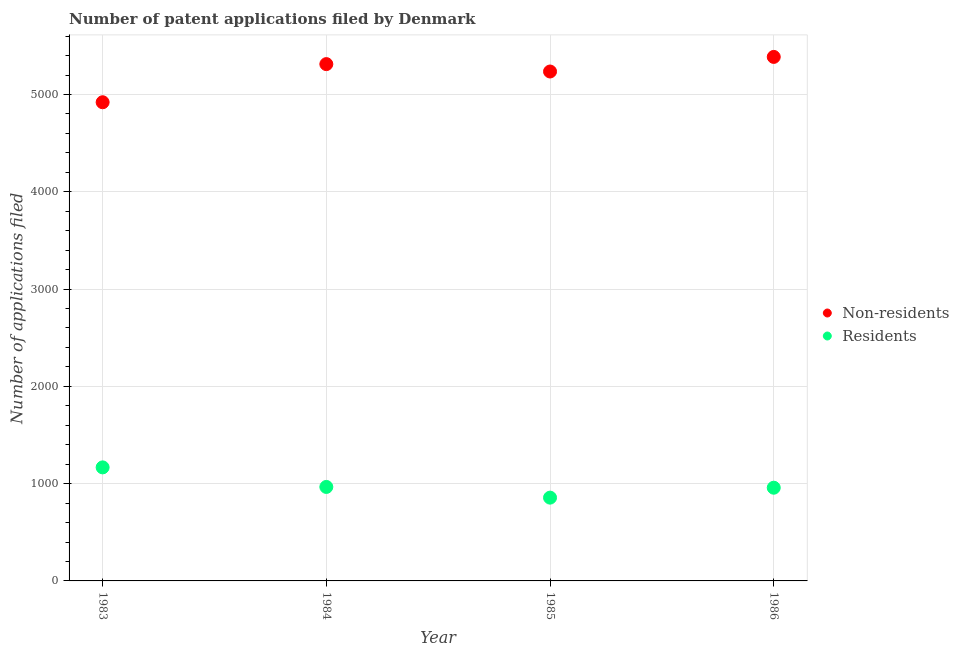How many different coloured dotlines are there?
Give a very brief answer. 2. What is the number of patent applications by residents in 1986?
Provide a short and direct response. 958. Across all years, what is the maximum number of patent applications by non residents?
Provide a short and direct response. 5386. Across all years, what is the minimum number of patent applications by residents?
Make the answer very short. 856. What is the total number of patent applications by non residents in the graph?
Ensure brevity in your answer.  2.09e+04. What is the difference between the number of patent applications by residents in 1984 and that in 1985?
Give a very brief answer. 110. What is the difference between the number of patent applications by non residents in 1983 and the number of patent applications by residents in 1986?
Provide a succinct answer. 3962. What is the average number of patent applications by non residents per year?
Ensure brevity in your answer.  5213.5. In the year 1986, what is the difference between the number of patent applications by non residents and number of patent applications by residents?
Keep it short and to the point. 4428. What is the ratio of the number of patent applications by residents in 1984 to that in 1986?
Offer a terse response. 1.01. What is the difference between the highest and the second highest number of patent applications by residents?
Your answer should be compact. 201. What is the difference between the highest and the lowest number of patent applications by non residents?
Provide a succinct answer. 466. Does the number of patent applications by non residents monotonically increase over the years?
Your response must be concise. No. What is the difference between two consecutive major ticks on the Y-axis?
Ensure brevity in your answer.  1000. Are the values on the major ticks of Y-axis written in scientific E-notation?
Ensure brevity in your answer.  No. Does the graph contain any zero values?
Your answer should be very brief. No. Where does the legend appear in the graph?
Make the answer very short. Center right. What is the title of the graph?
Provide a succinct answer. Number of patent applications filed by Denmark. Does "Female" appear as one of the legend labels in the graph?
Keep it short and to the point. No. What is the label or title of the Y-axis?
Your answer should be very brief. Number of applications filed. What is the Number of applications filed in Non-residents in 1983?
Make the answer very short. 4920. What is the Number of applications filed of Residents in 1983?
Provide a short and direct response. 1167. What is the Number of applications filed in Non-residents in 1984?
Offer a very short reply. 5312. What is the Number of applications filed of Residents in 1984?
Make the answer very short. 966. What is the Number of applications filed in Non-residents in 1985?
Keep it short and to the point. 5236. What is the Number of applications filed of Residents in 1985?
Your response must be concise. 856. What is the Number of applications filed of Non-residents in 1986?
Offer a very short reply. 5386. What is the Number of applications filed in Residents in 1986?
Give a very brief answer. 958. Across all years, what is the maximum Number of applications filed of Non-residents?
Provide a succinct answer. 5386. Across all years, what is the maximum Number of applications filed in Residents?
Provide a short and direct response. 1167. Across all years, what is the minimum Number of applications filed of Non-residents?
Provide a short and direct response. 4920. Across all years, what is the minimum Number of applications filed in Residents?
Keep it short and to the point. 856. What is the total Number of applications filed of Non-residents in the graph?
Your answer should be compact. 2.09e+04. What is the total Number of applications filed in Residents in the graph?
Give a very brief answer. 3947. What is the difference between the Number of applications filed of Non-residents in 1983 and that in 1984?
Provide a short and direct response. -392. What is the difference between the Number of applications filed of Residents in 1983 and that in 1984?
Give a very brief answer. 201. What is the difference between the Number of applications filed of Non-residents in 1983 and that in 1985?
Make the answer very short. -316. What is the difference between the Number of applications filed of Residents in 1983 and that in 1985?
Make the answer very short. 311. What is the difference between the Number of applications filed of Non-residents in 1983 and that in 1986?
Keep it short and to the point. -466. What is the difference between the Number of applications filed of Residents in 1983 and that in 1986?
Your answer should be compact. 209. What is the difference between the Number of applications filed of Residents in 1984 and that in 1985?
Offer a terse response. 110. What is the difference between the Number of applications filed in Non-residents in 1984 and that in 1986?
Provide a short and direct response. -74. What is the difference between the Number of applications filed of Non-residents in 1985 and that in 1986?
Your answer should be very brief. -150. What is the difference between the Number of applications filed in Residents in 1985 and that in 1986?
Offer a very short reply. -102. What is the difference between the Number of applications filed of Non-residents in 1983 and the Number of applications filed of Residents in 1984?
Keep it short and to the point. 3954. What is the difference between the Number of applications filed of Non-residents in 1983 and the Number of applications filed of Residents in 1985?
Your response must be concise. 4064. What is the difference between the Number of applications filed in Non-residents in 1983 and the Number of applications filed in Residents in 1986?
Your response must be concise. 3962. What is the difference between the Number of applications filed of Non-residents in 1984 and the Number of applications filed of Residents in 1985?
Your response must be concise. 4456. What is the difference between the Number of applications filed of Non-residents in 1984 and the Number of applications filed of Residents in 1986?
Your answer should be very brief. 4354. What is the difference between the Number of applications filed of Non-residents in 1985 and the Number of applications filed of Residents in 1986?
Keep it short and to the point. 4278. What is the average Number of applications filed of Non-residents per year?
Your response must be concise. 5213.5. What is the average Number of applications filed of Residents per year?
Keep it short and to the point. 986.75. In the year 1983, what is the difference between the Number of applications filed of Non-residents and Number of applications filed of Residents?
Your answer should be very brief. 3753. In the year 1984, what is the difference between the Number of applications filed in Non-residents and Number of applications filed in Residents?
Your answer should be very brief. 4346. In the year 1985, what is the difference between the Number of applications filed in Non-residents and Number of applications filed in Residents?
Your answer should be very brief. 4380. In the year 1986, what is the difference between the Number of applications filed in Non-residents and Number of applications filed in Residents?
Ensure brevity in your answer.  4428. What is the ratio of the Number of applications filed in Non-residents in 1983 to that in 1984?
Your answer should be compact. 0.93. What is the ratio of the Number of applications filed in Residents in 1983 to that in 1984?
Offer a very short reply. 1.21. What is the ratio of the Number of applications filed in Non-residents in 1983 to that in 1985?
Your answer should be very brief. 0.94. What is the ratio of the Number of applications filed of Residents in 1983 to that in 1985?
Provide a succinct answer. 1.36. What is the ratio of the Number of applications filed of Non-residents in 1983 to that in 1986?
Keep it short and to the point. 0.91. What is the ratio of the Number of applications filed of Residents in 1983 to that in 1986?
Your response must be concise. 1.22. What is the ratio of the Number of applications filed in Non-residents in 1984 to that in 1985?
Provide a short and direct response. 1.01. What is the ratio of the Number of applications filed in Residents in 1984 to that in 1985?
Offer a very short reply. 1.13. What is the ratio of the Number of applications filed of Non-residents in 1984 to that in 1986?
Provide a succinct answer. 0.99. What is the ratio of the Number of applications filed of Residents in 1984 to that in 1986?
Keep it short and to the point. 1.01. What is the ratio of the Number of applications filed in Non-residents in 1985 to that in 1986?
Provide a succinct answer. 0.97. What is the ratio of the Number of applications filed in Residents in 1985 to that in 1986?
Your answer should be very brief. 0.89. What is the difference between the highest and the second highest Number of applications filed of Residents?
Offer a terse response. 201. What is the difference between the highest and the lowest Number of applications filed of Non-residents?
Offer a terse response. 466. What is the difference between the highest and the lowest Number of applications filed of Residents?
Provide a succinct answer. 311. 